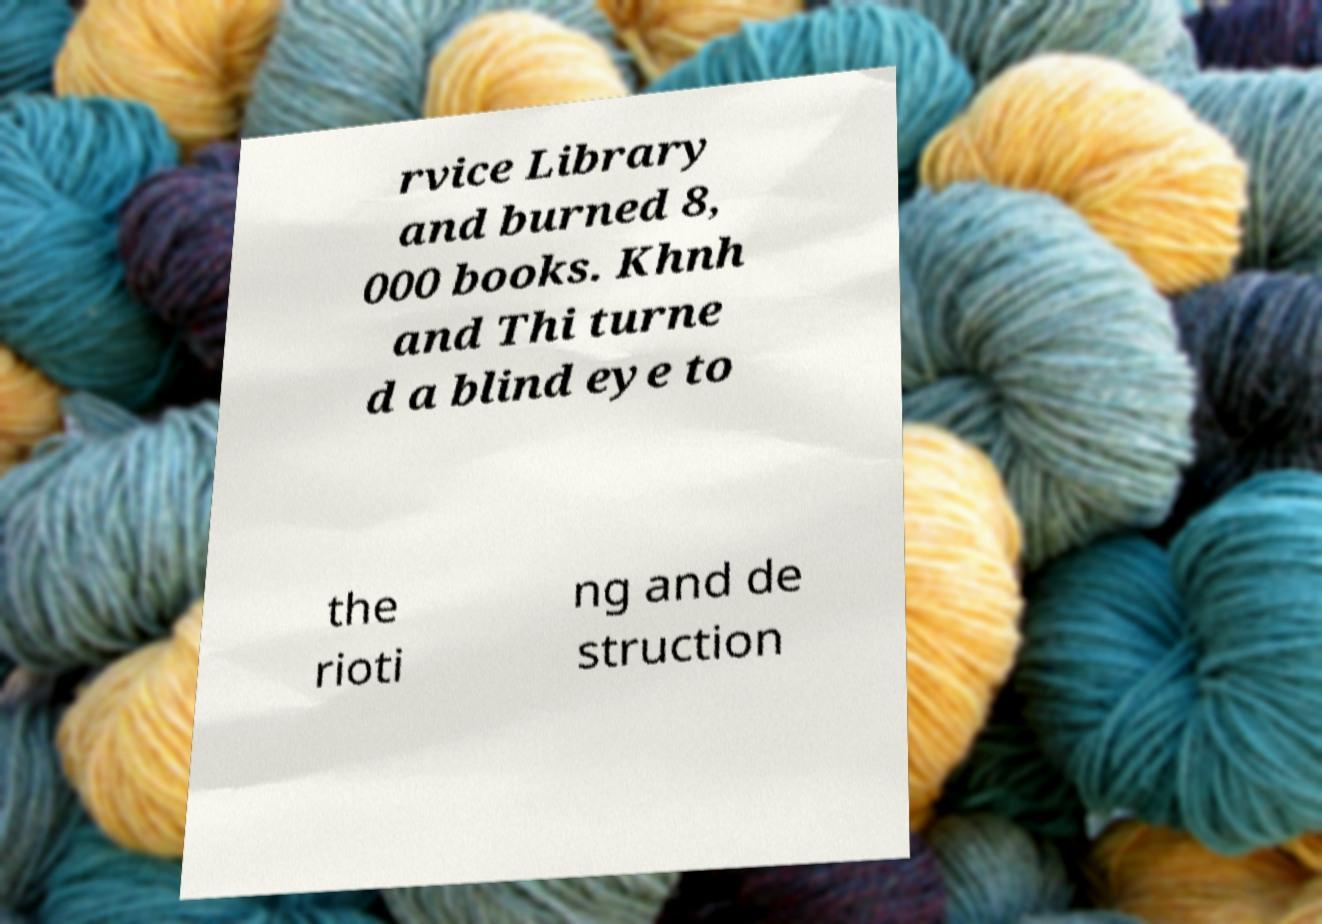There's text embedded in this image that I need extracted. Can you transcribe it verbatim? rvice Library and burned 8, 000 books. Khnh and Thi turne d a blind eye to the rioti ng and de struction 